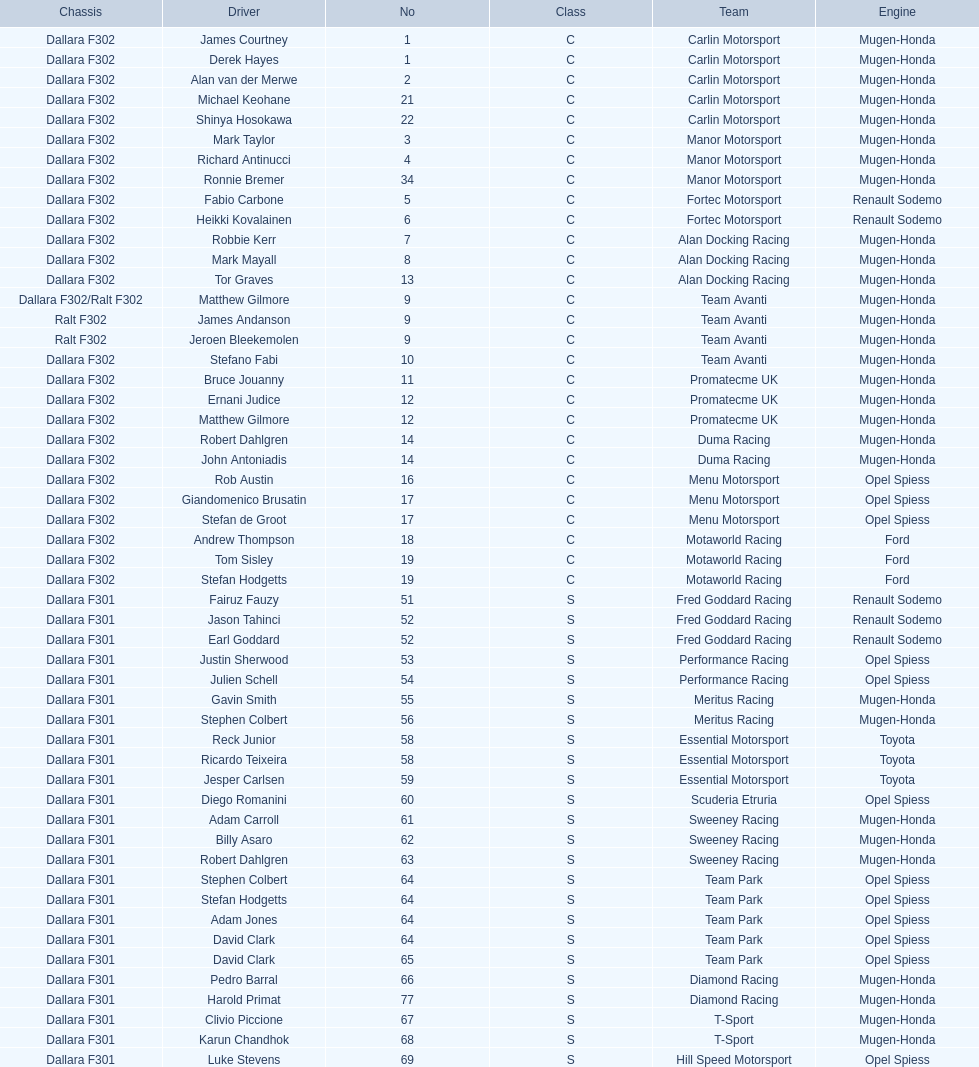Which engine was used the most by teams this season? Mugen-Honda. 